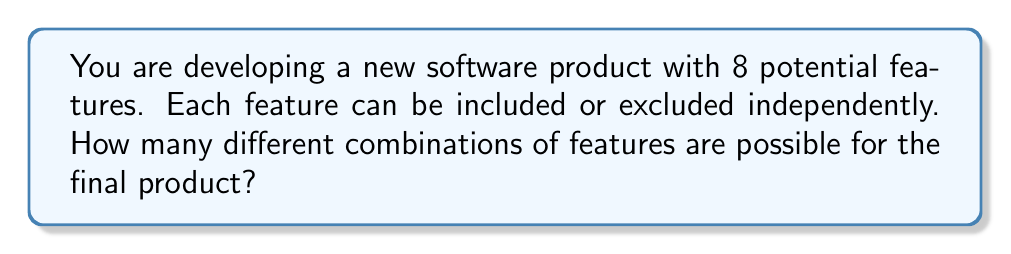Give your solution to this math problem. Let's approach this step-by-step:

1) For each feature, we have two choices: include it or exclude it.

2) This scenario represents a binary choice for each feature, which can be modeled using the multiplication principle.

3) With 8 features, and 2 choices for each feature, we can represent this mathematically as:

   $$2 \times 2 \times 2 \times 2 \times 2 \times 2 \times 2 \times 2$$

4) This is equivalent to $2^8$, as we're multiplying 2 by itself 8 times.

5) We can calculate this:

   $$2^8 = 2 \times 2 \times 2 \times 2 \times 2 \times 2 \times 2 \times 2 = 256$$

Therefore, there are 256 possible combinations of features for the final product.
Answer: $2^8 = 256$ 